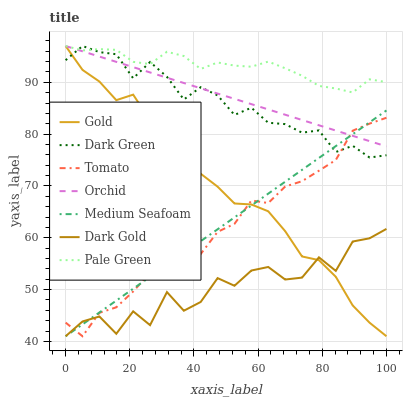Does Dark Gold have the minimum area under the curve?
Answer yes or no. Yes. Does Pale Green have the maximum area under the curve?
Answer yes or no. Yes. Does Gold have the minimum area under the curve?
Answer yes or no. No. Does Gold have the maximum area under the curve?
Answer yes or no. No. Is Medium Seafoam the smoothest?
Answer yes or no. Yes. Is Dark Gold the roughest?
Answer yes or no. Yes. Is Gold the smoothest?
Answer yes or no. No. Is Gold the roughest?
Answer yes or no. No. Does Tomato have the lowest value?
Answer yes or no. Yes. Does Pale Green have the lowest value?
Answer yes or no. No. Does Orchid have the highest value?
Answer yes or no. Yes. Does Dark Gold have the highest value?
Answer yes or no. No. Is Dark Gold less than Pale Green?
Answer yes or no. Yes. Is Pale Green greater than Medium Seafoam?
Answer yes or no. Yes. Does Medium Seafoam intersect Dark Gold?
Answer yes or no. Yes. Is Medium Seafoam less than Dark Gold?
Answer yes or no. No. Is Medium Seafoam greater than Dark Gold?
Answer yes or no. No. Does Dark Gold intersect Pale Green?
Answer yes or no. No. 